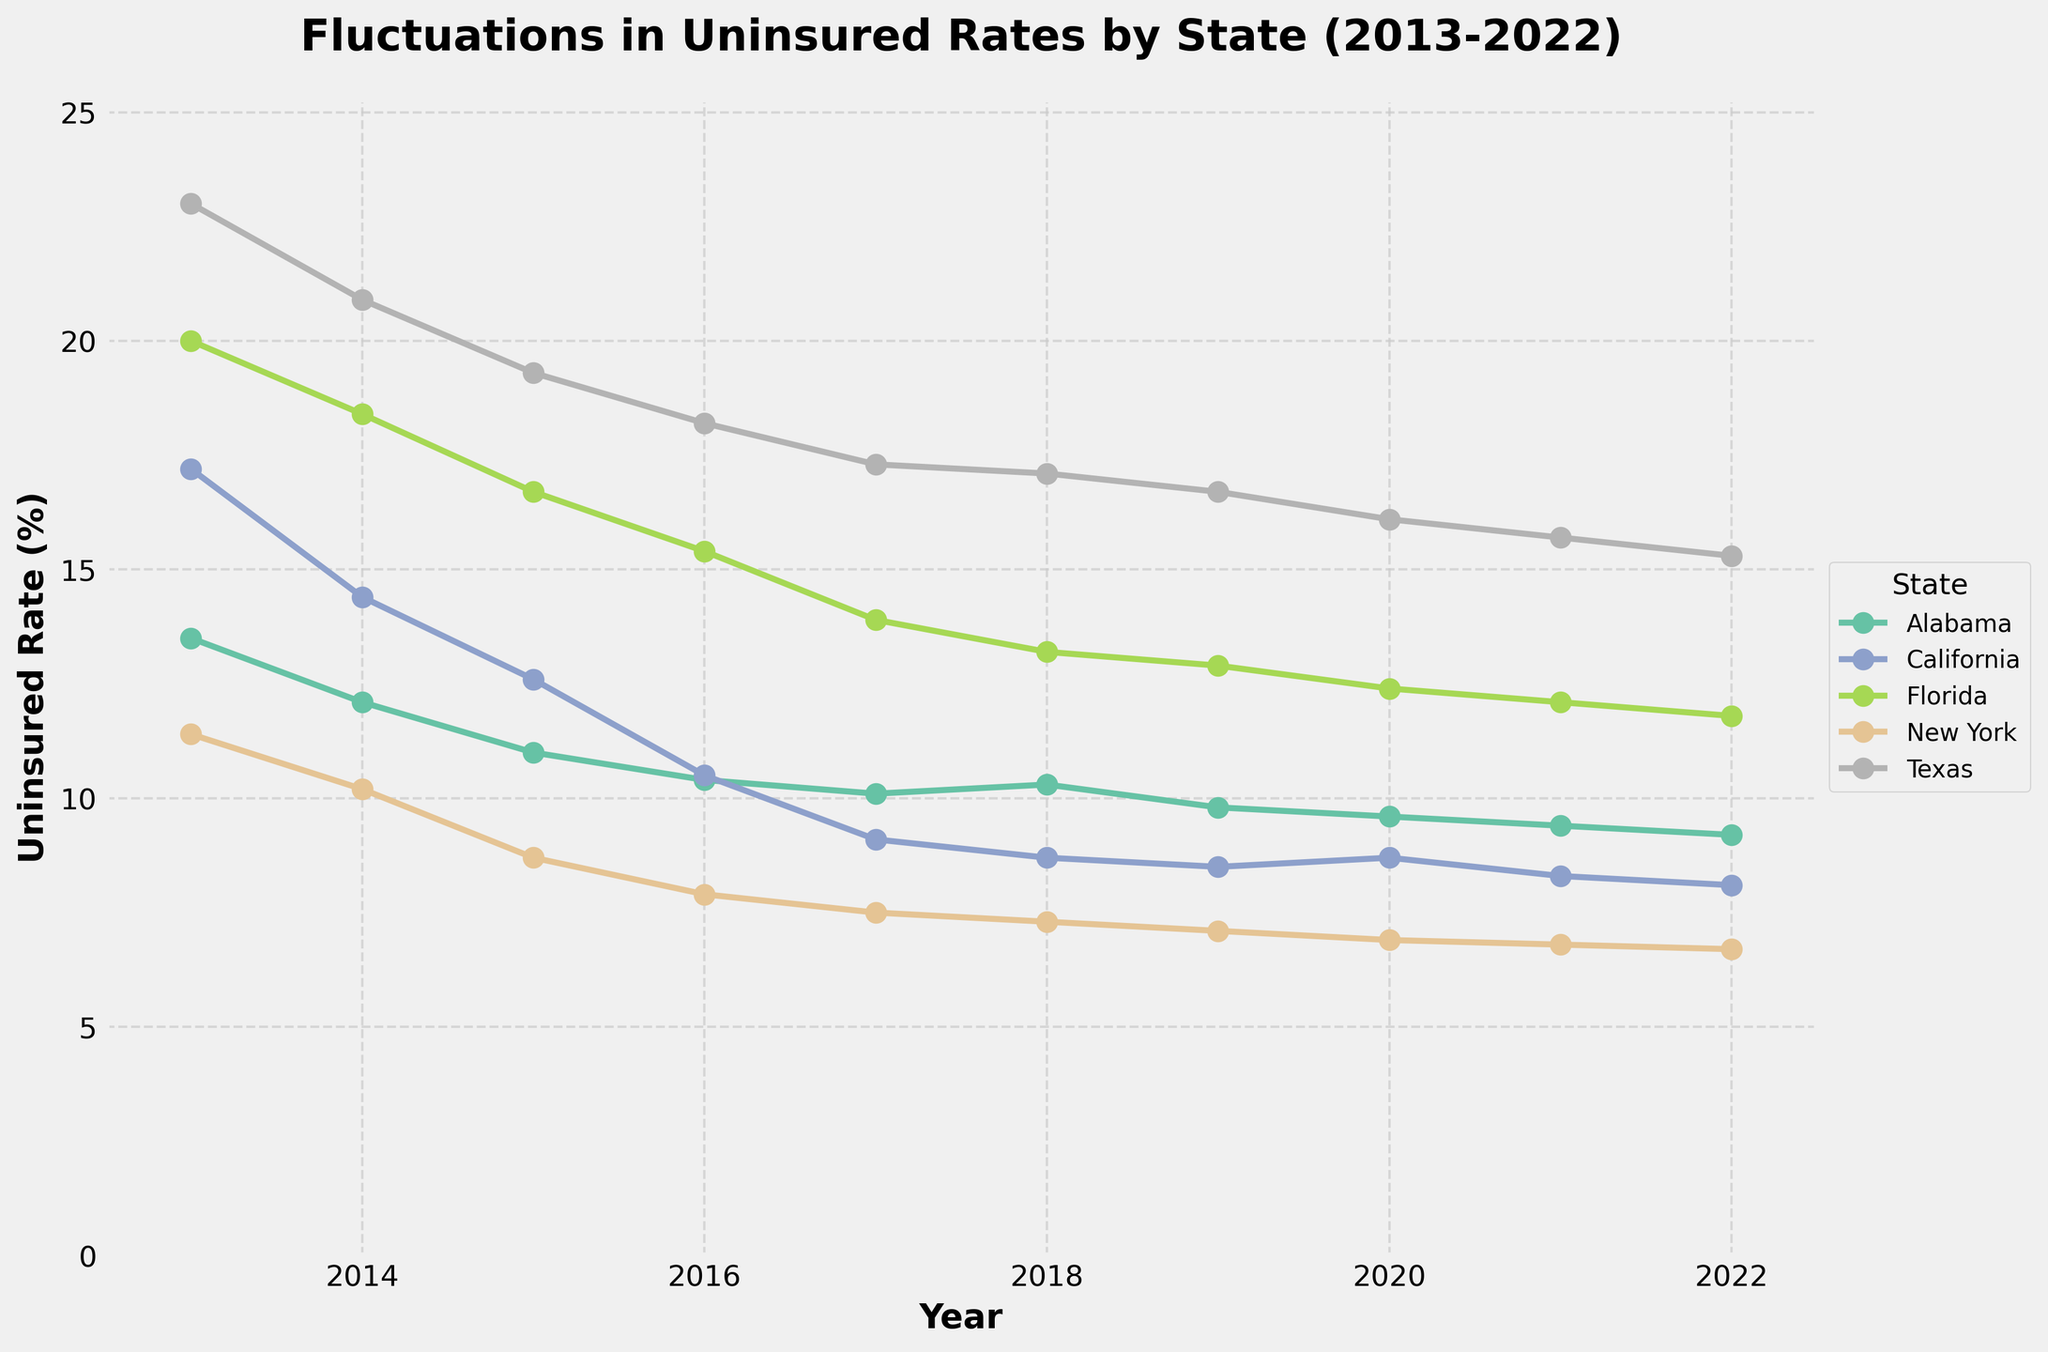What is the title of the plot? The title of the plot is displayed at the top and provides an overview of the subject matter being depicted. The title in this case is clearly noted at the top of the figure.
Answer: Fluctuations in Uninsured Rates by State (2013-2022) What are the y-axis labels? The y-axis on the left side of the plot indicates the measure of the data being analyzed. The label there describes what is being measured.
Answer: Uninsured Rate (%) Which state had the highest uninsured rate in 2013? Look at the year 2013 on the x-axis and trace up to see which line starts at the highest point.
Answer: Texas Which state experienced the largest decrease in uninsured rate from 2013 to 2022? Calculate the difference in uninsured rate between 2013 and 2022 for each state and determine which has the greatest reduction. For example, for Texas: 23.0 - 15.3 = 7.7; repeat for all states and compare.
Answer: Florida How did the uninsured rate in California change from 2017 to 2018? Observe the point on the California line at 2017 and compare it to the point at 2018.
Answer: It decreased from 9.1% to 8.7% Which year had the lowest uninsured rate in New York during the period? Find the lowest point on the New York line and match it to the corresponding year on the x-axis. New York's line is consistently decreasing, so check around the end of the period.
Answer: 2022 How many unique states are represented in the plot? Count the number of distinct lines, each representing a different state.
Answer: 5 Did any state see an increase in its uninsured rate after 2018? Look at each line after the year 2018 and see if any of the lines rise in value. Observe trends particularly at 2019 or later points.
Answer: Alabama and California Which state has the most stable uninsured rate (i.e., least fluctuations) from 2013 to 2022? Compare the lines visually and see which one has the smallest variations. The line that is the flattest or shows the least number of peaks and troughs is the most stable.
Answer: New York How does the uninsured rate in Texas compare to that in Florida for the year 2022? Find the points for Texas and Florida at the year 2022 and compare their vertical positions.
Answer: Texas has a higher uninsured rate (15.3% compared to Florida's 11.8%) 